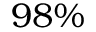<formula> <loc_0><loc_0><loc_500><loc_500>9 8 \%</formula> 